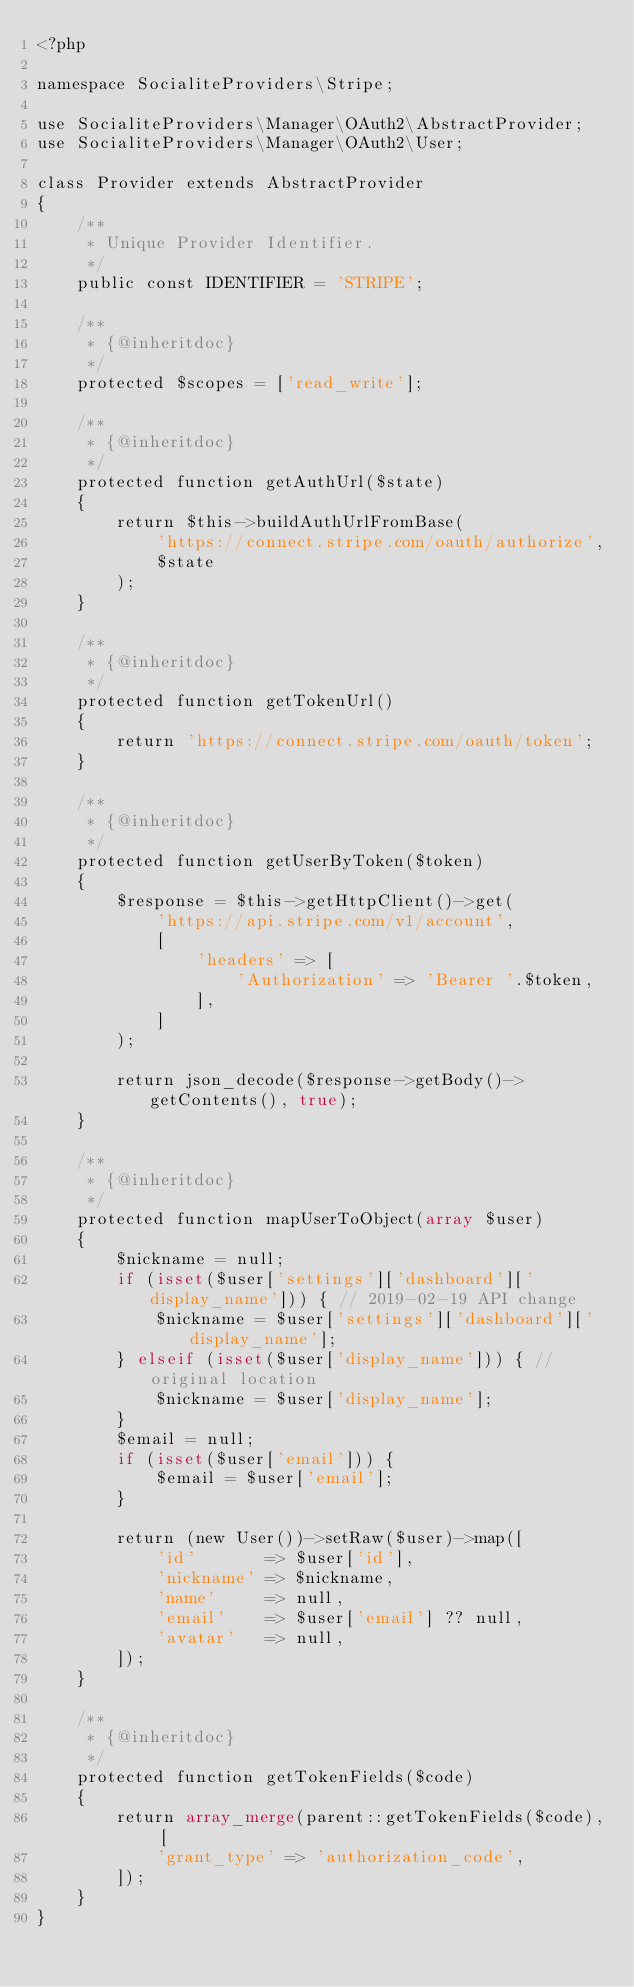Convert code to text. <code><loc_0><loc_0><loc_500><loc_500><_PHP_><?php

namespace SocialiteProviders\Stripe;

use SocialiteProviders\Manager\OAuth2\AbstractProvider;
use SocialiteProviders\Manager\OAuth2\User;

class Provider extends AbstractProvider
{
    /**
     * Unique Provider Identifier.
     */
    public const IDENTIFIER = 'STRIPE';

    /**
     * {@inheritdoc}
     */
    protected $scopes = ['read_write'];

    /**
     * {@inheritdoc}
     */
    protected function getAuthUrl($state)
    {
        return $this->buildAuthUrlFromBase(
            'https://connect.stripe.com/oauth/authorize',
            $state
        );
    }

    /**
     * {@inheritdoc}
     */
    protected function getTokenUrl()
    {
        return 'https://connect.stripe.com/oauth/token';
    }

    /**
     * {@inheritdoc}
     */
    protected function getUserByToken($token)
    {
        $response = $this->getHttpClient()->get(
            'https://api.stripe.com/v1/account',
            [
                'headers' => [
                    'Authorization' => 'Bearer '.$token,
                ],
            ]
        );

        return json_decode($response->getBody()->getContents(), true);
    }

    /**
     * {@inheritdoc}
     */
    protected function mapUserToObject(array $user)
    {
        $nickname = null;
        if (isset($user['settings']['dashboard']['display_name'])) { // 2019-02-19 API change
            $nickname = $user['settings']['dashboard']['display_name'];
        } elseif (isset($user['display_name'])) { // original location
            $nickname = $user['display_name'];
        }
        $email = null;
        if (isset($user['email'])) {
            $email = $user['email'];
        }

        return (new User())->setRaw($user)->map([
            'id'       => $user['id'],
            'nickname' => $nickname,
            'name'     => null,
            'email'    => $user['email'] ?? null,
            'avatar'   => null,
        ]);
    }

    /**
     * {@inheritdoc}
     */
    protected function getTokenFields($code)
    {
        return array_merge(parent::getTokenFields($code), [
            'grant_type' => 'authorization_code',
        ]);
    }
}
</code> 